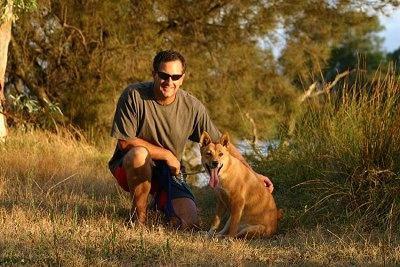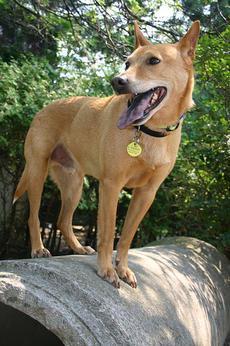The first image is the image on the left, the second image is the image on the right. For the images displayed, is the sentence "A dog is standing on all fours on something made of cement." factually correct? Answer yes or no. Yes. The first image is the image on the left, the second image is the image on the right. Given the left and right images, does the statement "Only one dog has its mouth open." hold true? Answer yes or no. No. 